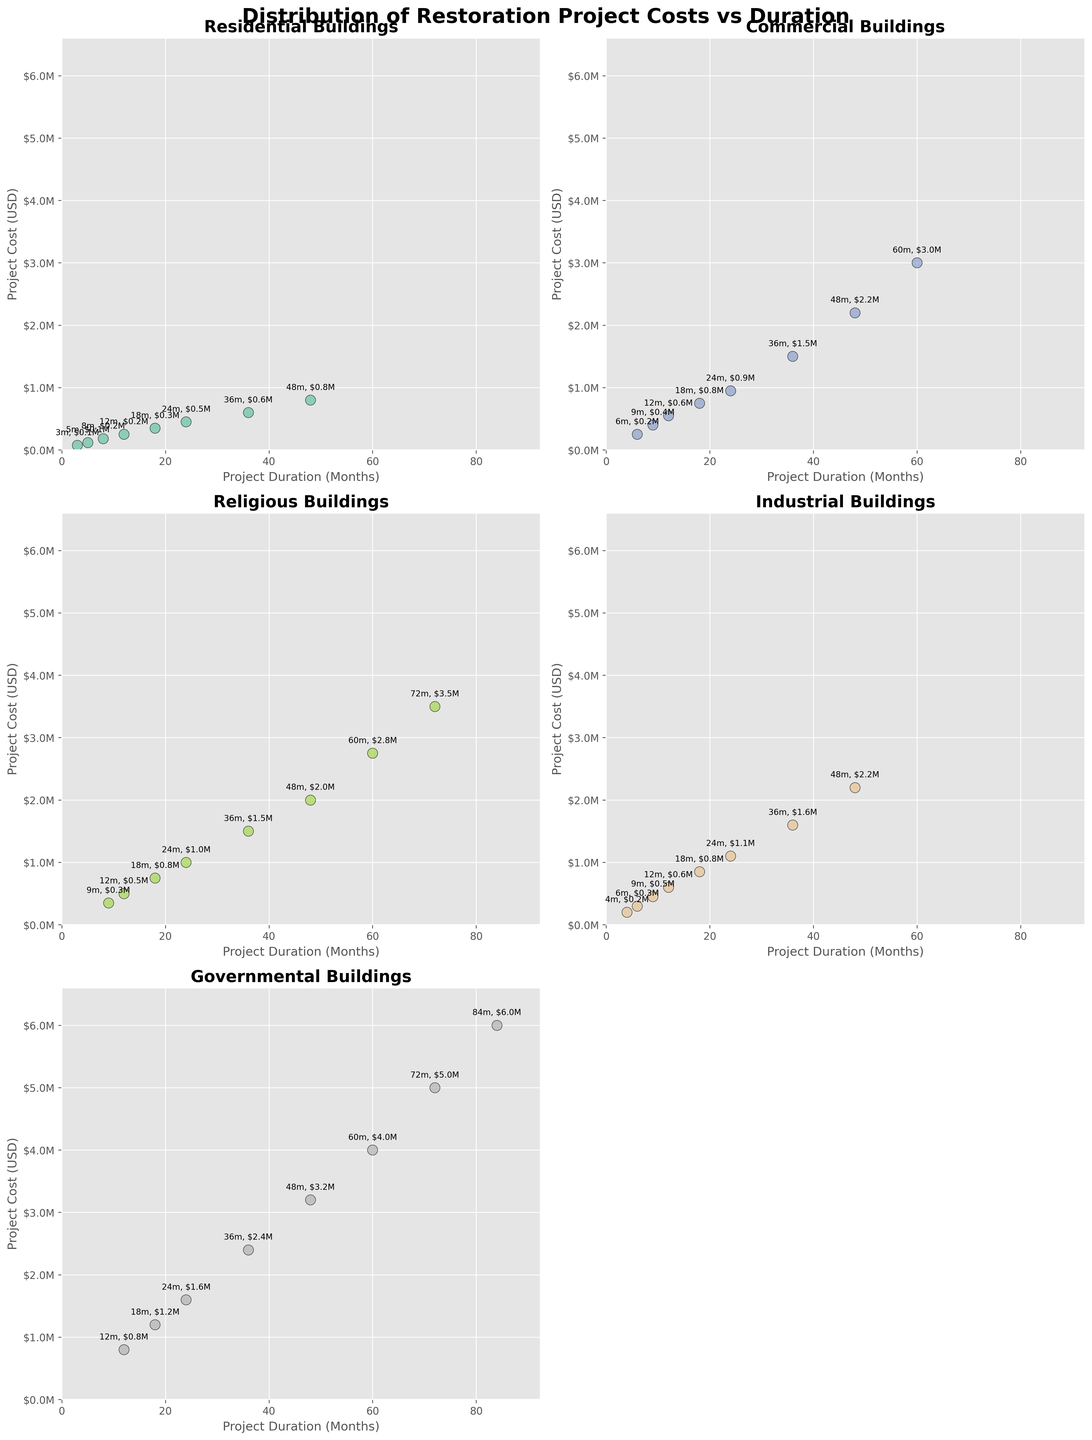Which project type has the highest cost for the shortest duration? To find this, look at the project type with the lowest duration value and compare the costs associated with it. The shortest duration is Residential at 3 months with a cost of $75,000.
Answer: Residential Which two project types have the highest final project cost? For each project type, look at the cost of the project with the longest duration and compare them. Governmental has the highest final project cost with $6,000,000, followed by Religious with $3,500,000.
Answer: Governmental, Religious What is the range of project durations for Commercial buildings? The duration for Commercial buildings ranges from 6 months to 60 months.
Answer: 6 to 60 months For which project type are the durations evenly spaced? Evaluate the increment in duration for each project type. Residential increments are uneven, Commercial increases every 6 or 12 months, Religious increases every 12 months, Industrial increases in varied increments, and Governmental increases every 12 months, hence durations are evenly spaced for Governmental.
Answer: Governmental How does the project cost relate to duration for Governmental buildings? Plot observation shows that project cost increases linearly with duration for Governmental buildings.
Answer: Linearly Which project type has the lowest increase in cost relative to duration over the given data? For each project type, calculate the cost change per month. Residential (450,000/24) ≈ 18,750/month, Commercial (3,000,000/60) = 50,000/month, Religious (3,500,000/72) ≈ 48,611/month, Industrial (2,200,000/48) ≈ 45,833/month, Governmental (6,000,000/84) ≈ 71,429/month. Residential has the lowest increment.
Answer: Residential What is the average cost of all Commercial building projects shown? Sum up all the costs for Commercial projects and divide by the number of projects: (250,000 + 400,000 + 550,000 + 750,000 + 950,000 + 1,500,000 + 2,200,000 + 3,000,000)/8 = 1,200,000.
Answer: $1,200,000 Which project type reaches a $1,500,000 cost the earliest? Find the first project that reaches a cost of $1,500,000 or more for each type. For Residential, it never reaches. For Commercial, it reaches at 36 months. For Religious, it reaches at 36 months. For Industrial, it reaches at 36 months. For Governmental, it reaches at 36 months. Hence, they all tie.
Answer: Commercial, Religious, Industrial, Governmental 